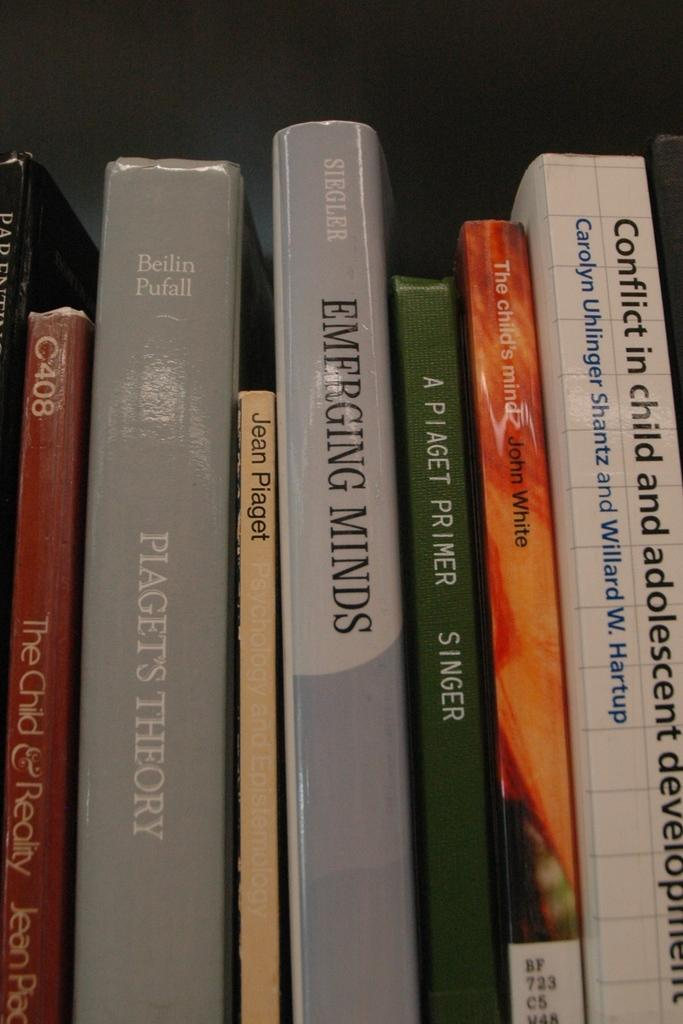<image>
Create a compact narrative representing the image presented. various books on a shelf including emerging minds 